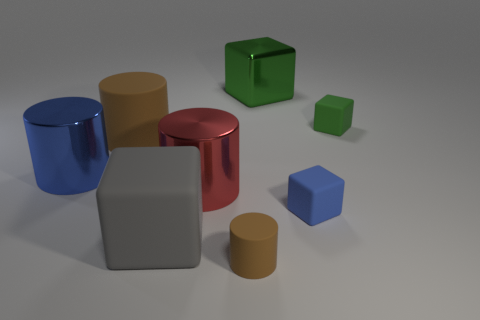Subtract all tiny blue matte cubes. How many cubes are left? 3 Add 2 small yellow metal balls. How many objects exist? 10 Subtract all blue cylinders. How many cylinders are left? 3 Subtract 3 cubes. How many cubes are left? 1 Subtract all yellow cylinders. Subtract all green balls. How many cylinders are left? 4 Subtract all brown cylinders. How many blue cubes are left? 1 Subtract all tiny red metallic balls. Subtract all big green shiny things. How many objects are left? 7 Add 2 matte objects. How many matte objects are left? 7 Add 6 big cyan metallic spheres. How many big cyan metallic spheres exist? 6 Subtract 0 cyan balls. How many objects are left? 8 